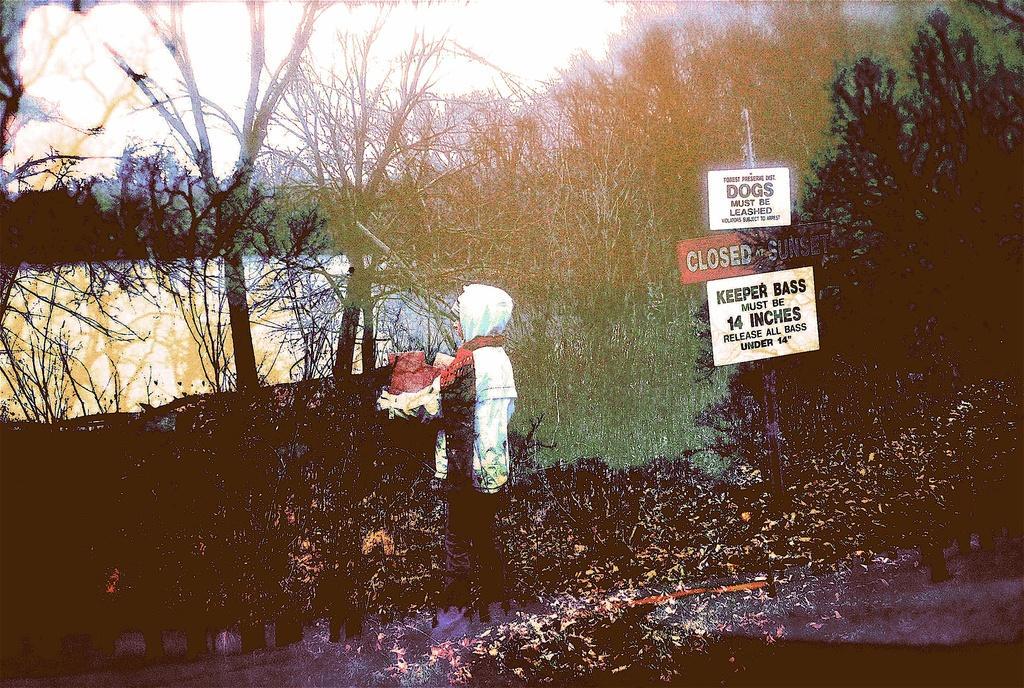Could you give a brief overview of what you see in this image? In this image I can see a person. On the right side, I can see some boards with some text written on it. In the background, I can see the trees. 